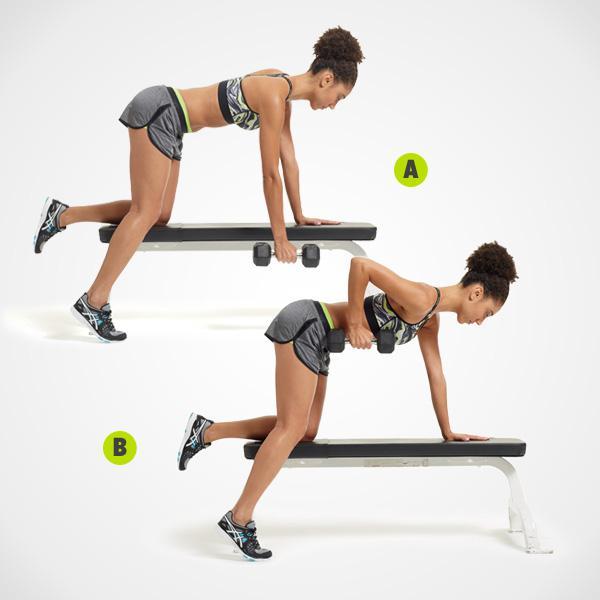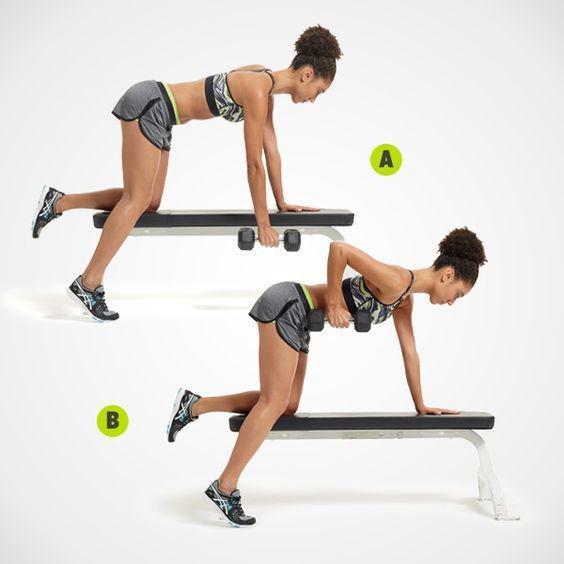The first image is the image on the left, the second image is the image on the right. For the images shown, is this caption "There is only one man in at least one image." true? Answer yes or no. No. 